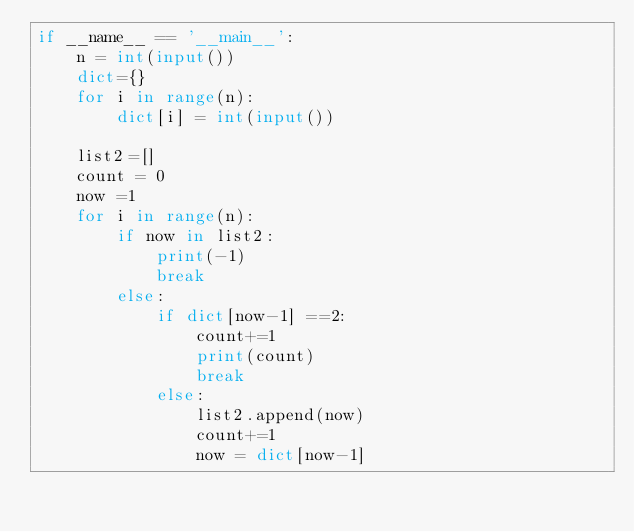<code> <loc_0><loc_0><loc_500><loc_500><_Python_>if __name__ == '__main__':
    n = int(input())
    dict={}
    for i in range(n):
        dict[i] = int(input())

    list2=[]
    count = 0
    now =1
    for i in range(n):
        if now in list2:
            print(-1)
            break
        else:
            if dict[now-1] ==2:
                count+=1
                print(count)
                break
            else:
                list2.append(now)
                count+=1
                now = dict[now-1]</code> 